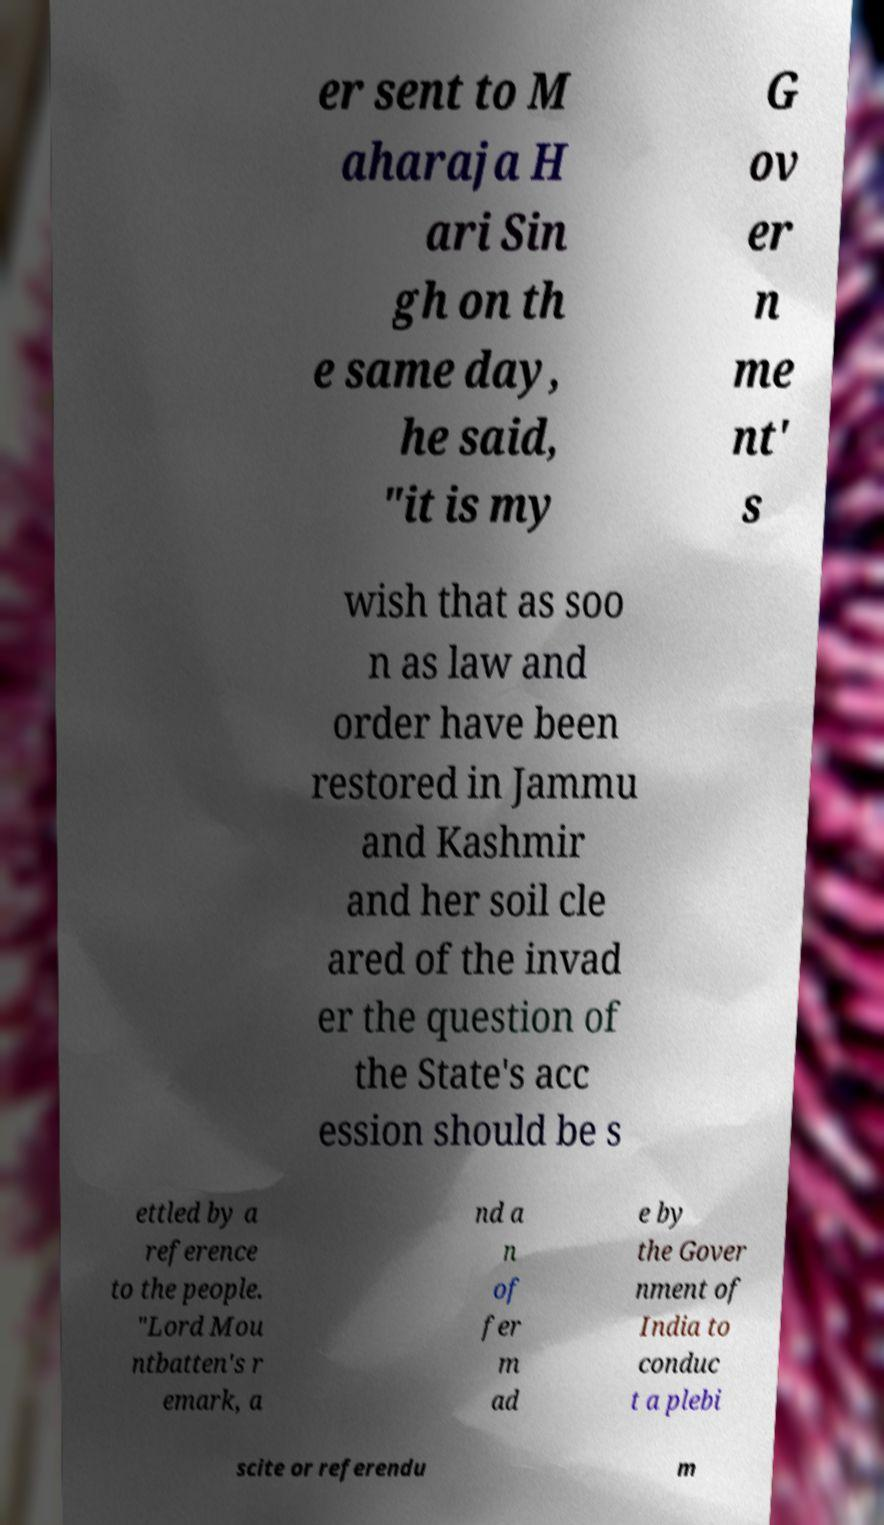Can you read and provide the text displayed in the image?This photo seems to have some interesting text. Can you extract and type it out for me? er sent to M aharaja H ari Sin gh on th e same day, he said, "it is my G ov er n me nt' s wish that as soo n as law and order have been restored in Jammu and Kashmir and her soil cle ared of the invad er the question of the State's acc ession should be s ettled by a reference to the people. "Lord Mou ntbatten's r emark, a nd a n of fer m ad e by the Gover nment of India to conduc t a plebi scite or referendu m 